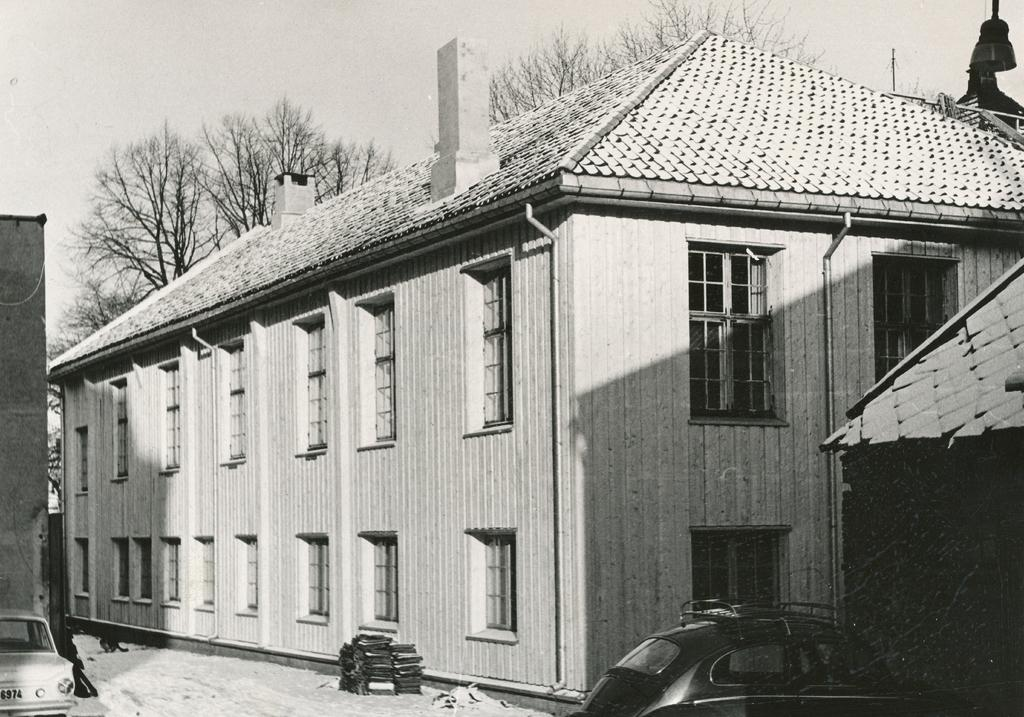What type of structure is present in the image? There is a building in the image. What can be seen attached to the building? There are pipelines and windows visible on the building. What type of vegetation is present in the image? There are trees in the image. What is visible in the sky? The sky is visible in the image. What type of lighting is present in the image? There is a street bulb in the image. What type of vehicles are present in the image? There are cars in the image. What type of weather condition is depicted in the image? There is snow in the image. What type of feature is present on the building? There is a chimney in the image. How many icicles are hanging from the chimney in the image? There are no icicles visible in the image. What type of lead is used to connect the pipelines in the image? There is no mention of lead being used to connect the pipelines in the image. What type of soap is used to clean the windows in the image? There is no indication of any soap being used to clean the windows in the image. 